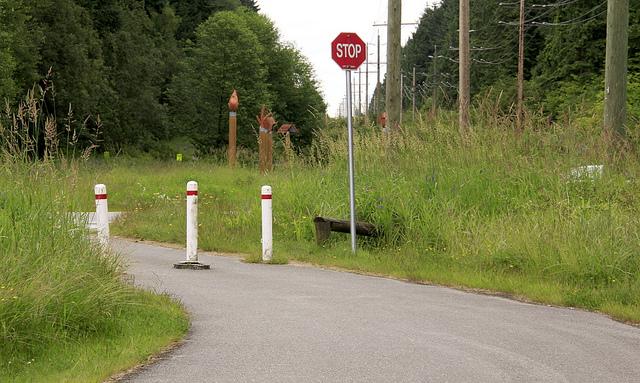What color is the grass?
Write a very short answer. Green. What color is the sign?
Answer briefly. Red. Can you pass here?
Keep it brief. No. 